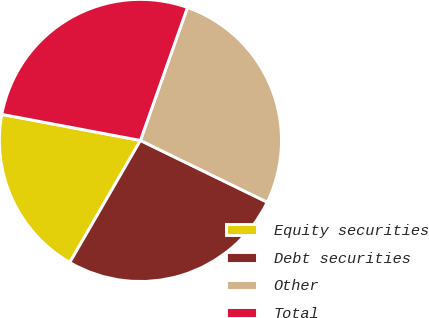Convert chart to OTSL. <chart><loc_0><loc_0><loc_500><loc_500><pie_chart><fcel>Equity securities<fcel>Debt securities<fcel>Other<fcel>Total<nl><fcel>19.61%<fcel>26.14%<fcel>26.8%<fcel>27.45%<nl></chart> 